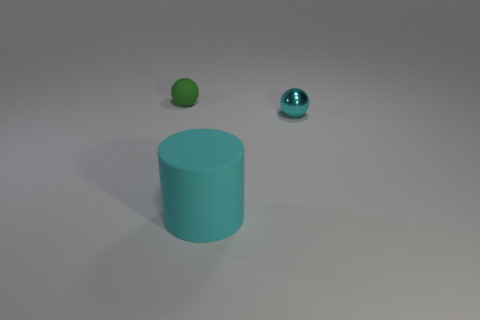Add 3 gray shiny balls. How many objects exist? 6 Subtract all balls. How many objects are left? 1 Subtract all small matte spheres. Subtract all green balls. How many objects are left? 1 Add 3 cyan cylinders. How many cyan cylinders are left? 4 Add 2 big green shiny balls. How many big green shiny balls exist? 2 Subtract 0 cyan cubes. How many objects are left? 3 